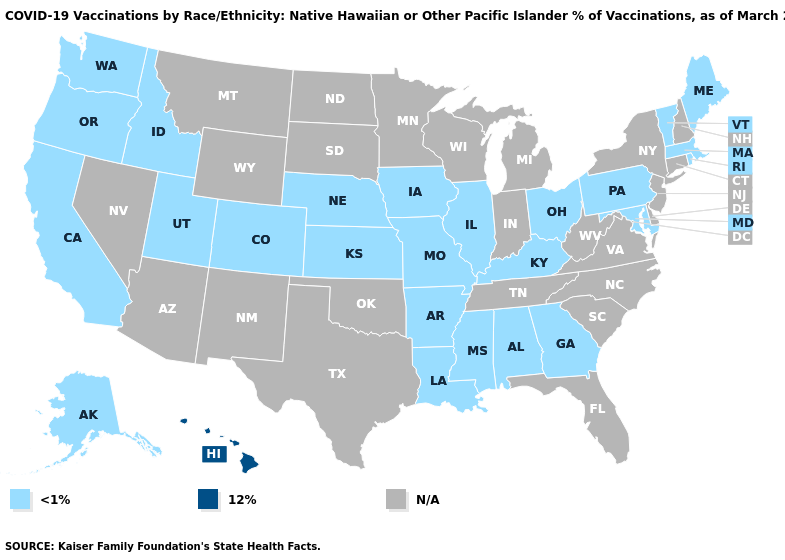Name the states that have a value in the range N/A?
Keep it brief. Arizona, Connecticut, Delaware, Florida, Indiana, Michigan, Minnesota, Montana, Nevada, New Hampshire, New Jersey, New Mexico, New York, North Carolina, North Dakota, Oklahoma, South Carolina, South Dakota, Tennessee, Texas, Virginia, West Virginia, Wisconsin, Wyoming. Name the states that have a value in the range <1%?
Short answer required. Alabama, Alaska, Arkansas, California, Colorado, Georgia, Idaho, Illinois, Iowa, Kansas, Kentucky, Louisiana, Maine, Maryland, Massachusetts, Mississippi, Missouri, Nebraska, Ohio, Oregon, Pennsylvania, Rhode Island, Utah, Vermont, Washington. Name the states that have a value in the range N/A?
Give a very brief answer. Arizona, Connecticut, Delaware, Florida, Indiana, Michigan, Minnesota, Montana, Nevada, New Hampshire, New Jersey, New Mexico, New York, North Carolina, North Dakota, Oklahoma, South Carolina, South Dakota, Tennessee, Texas, Virginia, West Virginia, Wisconsin, Wyoming. What is the lowest value in states that border Washington?
Short answer required. <1%. Is the legend a continuous bar?
Give a very brief answer. No. Name the states that have a value in the range 12%?
Give a very brief answer. Hawaii. Name the states that have a value in the range N/A?
Give a very brief answer. Arizona, Connecticut, Delaware, Florida, Indiana, Michigan, Minnesota, Montana, Nevada, New Hampshire, New Jersey, New Mexico, New York, North Carolina, North Dakota, Oklahoma, South Carolina, South Dakota, Tennessee, Texas, Virginia, West Virginia, Wisconsin, Wyoming. What is the value of Vermont?
Quick response, please. <1%. What is the value of Illinois?
Answer briefly. <1%. What is the value of New York?
Short answer required. N/A. Name the states that have a value in the range N/A?
Keep it brief. Arizona, Connecticut, Delaware, Florida, Indiana, Michigan, Minnesota, Montana, Nevada, New Hampshire, New Jersey, New Mexico, New York, North Carolina, North Dakota, Oklahoma, South Carolina, South Dakota, Tennessee, Texas, Virginia, West Virginia, Wisconsin, Wyoming. What is the value of Indiana?
Keep it brief. N/A. What is the value of Rhode Island?
Answer briefly. <1%. Among the states that border Arizona , which have the highest value?
Write a very short answer. California, Colorado, Utah. What is the value of Maine?
Give a very brief answer. <1%. 